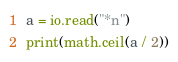Convert code to text. <code><loc_0><loc_0><loc_500><loc_500><_Lua_>a = io.read("*n")
print(math.ceil(a / 2))</code> 